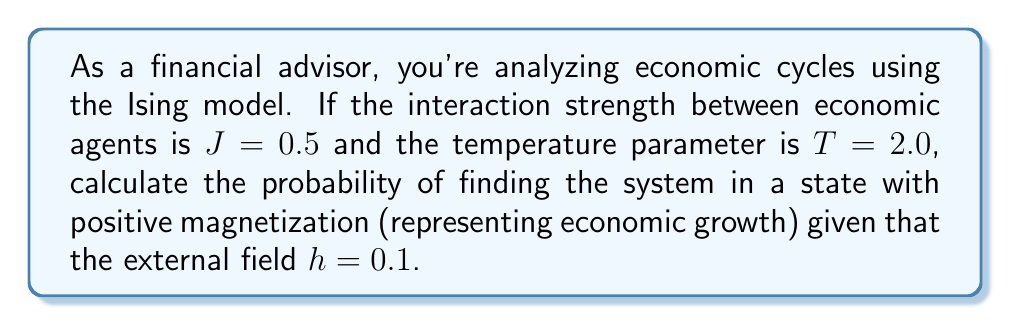Provide a solution to this math problem. To solve this problem, we'll use the Ising model adapted for economic cycles:

1. In the Ising model, the probability of a state is given by the Boltzmann distribution:
   $$P(s) \propto e^{-\beta H(s)}$$
   where $\beta = \frac{1}{k_B T}$ and $H(s)$ is the Hamiltonian.

2. For simplicity, we'll consider a two-state system (growth or recession). The Hamiltonian for this system is:
   $$H(s) = -Js^2 - hs$$
   where $s = \pm 1$ represents the state of the economy.

3. Calculate $\beta$:
   $$\beta = \frac{1}{k_B T} = \frac{1}{2.0} = 0.5$$
   (assuming $k_B = 1$ for simplicity)

4. Calculate the energy for the positive state ($s = +1$):
   $$H(+1) = -J(+1)^2 - h(+1) = -0.5 - 0.1 = -0.6$$

5. Calculate the energy for the negative state ($s = -1$):
   $$H(-1) = -J(-1)^2 - h(-1) = -0.5 + 0.1 = -0.4$$

6. Calculate the unnormalized probabilities:
   $$P(+1) \propto e^{-\beta H(+1)} = e^{-0.5 \cdot (-0.6)} = e^{0.3}$$
   $$P(-1) \propto e^{-\beta H(-1)} = e^{-0.5 \cdot (-0.4)} = e^{0.2}$$

7. Calculate the normalization factor (partition function):
   $$Z = e^{0.3} + e^{0.2}$$

8. Calculate the normalized probability of the positive state:
   $$P(+1) = \frac{e^{0.3}}{e^{0.3} + e^{0.2}}$$

9. Simplify:
   $$P(+1) = \frac{e^{0.3}}{e^{0.3} + e^{0.2}} = \frac{e^{0.1}}{e^{0.1} + 1} = \frac{e^{0.1}}{1 + e^{-0.1}}$$
Answer: $\frac{e^{0.1}}{1 + e^{-0.1}} \approx 0.5250$ 